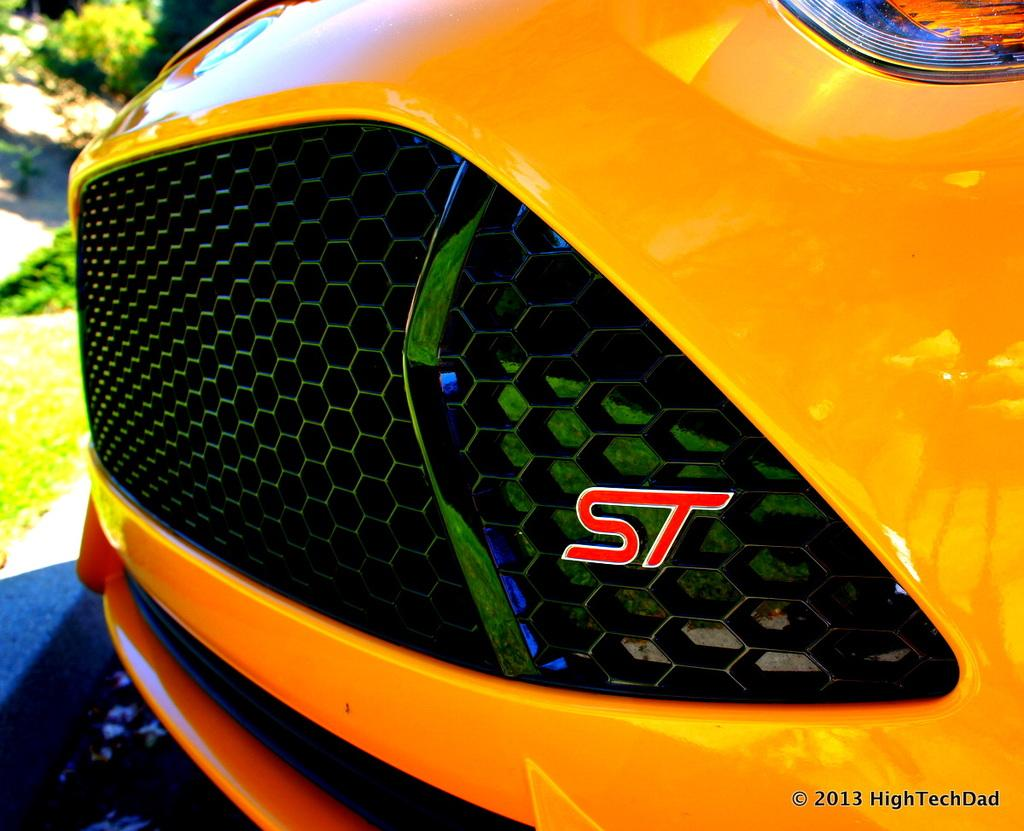What part of a vehicle can be seen in the image? The bumper of a car is visible in the image. What type of vegetation is on the left side of the image? There are plants and grass on the left side of the image. Is there any text present in the image? Yes, there is text at the bottom of the image. Can you see a coil in the image? There is no coil present in the image. What type of hand is shown interacting with the plants in the image? There are no hands visible in the image; only the car bumper, plants, grass, and text are present. 